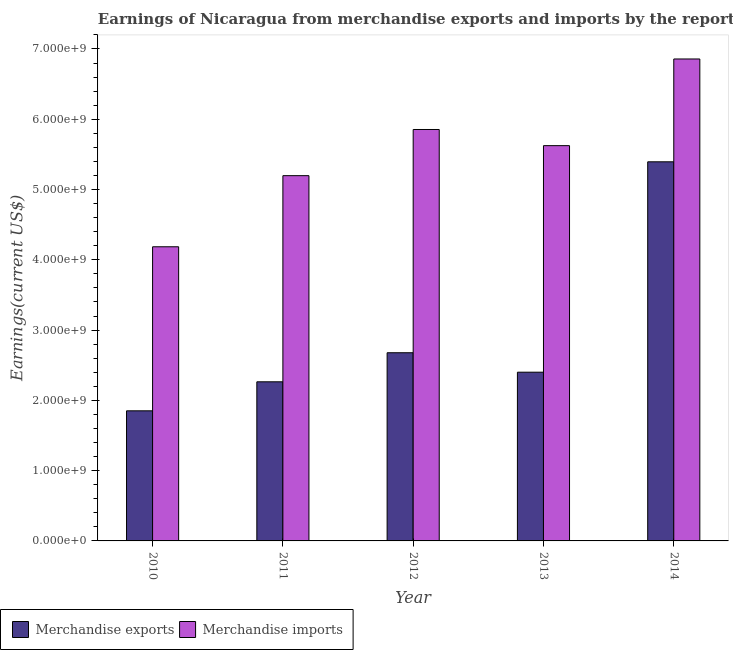How many different coloured bars are there?
Give a very brief answer. 2. How many groups of bars are there?
Your answer should be compact. 5. Are the number of bars per tick equal to the number of legend labels?
Make the answer very short. Yes. How many bars are there on the 2nd tick from the left?
Your answer should be very brief. 2. How many bars are there on the 3rd tick from the right?
Ensure brevity in your answer.  2. What is the earnings from merchandise imports in 2014?
Offer a terse response. 6.86e+09. Across all years, what is the maximum earnings from merchandise exports?
Make the answer very short. 5.39e+09. Across all years, what is the minimum earnings from merchandise imports?
Your response must be concise. 4.19e+09. In which year was the earnings from merchandise exports maximum?
Ensure brevity in your answer.  2014. In which year was the earnings from merchandise exports minimum?
Ensure brevity in your answer.  2010. What is the total earnings from merchandise exports in the graph?
Offer a very short reply. 1.46e+1. What is the difference between the earnings from merchandise imports in 2013 and that in 2014?
Ensure brevity in your answer.  -1.23e+09. What is the difference between the earnings from merchandise exports in 2014 and the earnings from merchandise imports in 2010?
Make the answer very short. 3.54e+09. What is the average earnings from merchandise imports per year?
Offer a terse response. 5.54e+09. In the year 2011, what is the difference between the earnings from merchandise imports and earnings from merchandise exports?
Offer a very short reply. 0. In how many years, is the earnings from merchandise imports greater than 4000000000 US$?
Your answer should be very brief. 5. What is the ratio of the earnings from merchandise exports in 2011 to that in 2013?
Provide a succinct answer. 0.94. Is the earnings from merchandise exports in 2011 less than that in 2013?
Your answer should be very brief. Yes. What is the difference between the highest and the second highest earnings from merchandise exports?
Give a very brief answer. 2.72e+09. What is the difference between the highest and the lowest earnings from merchandise exports?
Provide a succinct answer. 3.54e+09. In how many years, is the earnings from merchandise imports greater than the average earnings from merchandise imports taken over all years?
Provide a succinct answer. 3. Is the sum of the earnings from merchandise imports in 2011 and 2013 greater than the maximum earnings from merchandise exports across all years?
Give a very brief answer. Yes. What does the 1st bar from the left in 2013 represents?
Keep it short and to the point. Merchandise exports. How many bars are there?
Ensure brevity in your answer.  10. Are all the bars in the graph horizontal?
Your answer should be very brief. No. How many years are there in the graph?
Your response must be concise. 5. What is the difference between two consecutive major ticks on the Y-axis?
Your response must be concise. 1.00e+09. Does the graph contain any zero values?
Provide a short and direct response. No. Does the graph contain grids?
Ensure brevity in your answer.  No. How many legend labels are there?
Offer a very short reply. 2. How are the legend labels stacked?
Offer a very short reply. Horizontal. What is the title of the graph?
Offer a terse response. Earnings of Nicaragua from merchandise exports and imports by the reporting economy. What is the label or title of the Y-axis?
Provide a succinct answer. Earnings(current US$). What is the Earnings(current US$) in Merchandise exports in 2010?
Keep it short and to the point. 1.85e+09. What is the Earnings(current US$) of Merchandise imports in 2010?
Your response must be concise. 4.19e+09. What is the Earnings(current US$) of Merchandise exports in 2011?
Your answer should be compact. 2.26e+09. What is the Earnings(current US$) of Merchandise imports in 2011?
Offer a terse response. 5.20e+09. What is the Earnings(current US$) of Merchandise exports in 2012?
Make the answer very short. 2.68e+09. What is the Earnings(current US$) in Merchandise imports in 2012?
Ensure brevity in your answer.  5.85e+09. What is the Earnings(current US$) of Merchandise exports in 2013?
Make the answer very short. 2.40e+09. What is the Earnings(current US$) in Merchandise imports in 2013?
Your response must be concise. 5.62e+09. What is the Earnings(current US$) in Merchandise exports in 2014?
Provide a succinct answer. 5.39e+09. What is the Earnings(current US$) of Merchandise imports in 2014?
Keep it short and to the point. 6.86e+09. Across all years, what is the maximum Earnings(current US$) in Merchandise exports?
Give a very brief answer. 5.39e+09. Across all years, what is the maximum Earnings(current US$) in Merchandise imports?
Keep it short and to the point. 6.86e+09. Across all years, what is the minimum Earnings(current US$) of Merchandise exports?
Give a very brief answer. 1.85e+09. Across all years, what is the minimum Earnings(current US$) of Merchandise imports?
Make the answer very short. 4.19e+09. What is the total Earnings(current US$) in Merchandise exports in the graph?
Your answer should be very brief. 1.46e+1. What is the total Earnings(current US$) in Merchandise imports in the graph?
Ensure brevity in your answer.  2.77e+1. What is the difference between the Earnings(current US$) of Merchandise exports in 2010 and that in 2011?
Give a very brief answer. -4.13e+08. What is the difference between the Earnings(current US$) of Merchandise imports in 2010 and that in 2011?
Keep it short and to the point. -1.01e+09. What is the difference between the Earnings(current US$) in Merchandise exports in 2010 and that in 2012?
Keep it short and to the point. -8.26e+08. What is the difference between the Earnings(current US$) in Merchandise imports in 2010 and that in 2012?
Give a very brief answer. -1.67e+09. What is the difference between the Earnings(current US$) of Merchandise exports in 2010 and that in 2013?
Your answer should be compact. -5.50e+08. What is the difference between the Earnings(current US$) in Merchandise imports in 2010 and that in 2013?
Offer a terse response. -1.44e+09. What is the difference between the Earnings(current US$) of Merchandise exports in 2010 and that in 2014?
Offer a very short reply. -3.54e+09. What is the difference between the Earnings(current US$) in Merchandise imports in 2010 and that in 2014?
Your response must be concise. -2.67e+09. What is the difference between the Earnings(current US$) in Merchandise exports in 2011 and that in 2012?
Offer a terse response. -4.13e+08. What is the difference between the Earnings(current US$) of Merchandise imports in 2011 and that in 2012?
Your answer should be very brief. -6.57e+08. What is the difference between the Earnings(current US$) in Merchandise exports in 2011 and that in 2013?
Make the answer very short. -1.37e+08. What is the difference between the Earnings(current US$) of Merchandise imports in 2011 and that in 2013?
Provide a succinct answer. -4.27e+08. What is the difference between the Earnings(current US$) of Merchandise exports in 2011 and that in 2014?
Ensure brevity in your answer.  -3.13e+09. What is the difference between the Earnings(current US$) in Merchandise imports in 2011 and that in 2014?
Your answer should be compact. -1.66e+09. What is the difference between the Earnings(current US$) in Merchandise exports in 2012 and that in 2013?
Make the answer very short. 2.77e+08. What is the difference between the Earnings(current US$) in Merchandise imports in 2012 and that in 2013?
Your response must be concise. 2.30e+08. What is the difference between the Earnings(current US$) of Merchandise exports in 2012 and that in 2014?
Your response must be concise. -2.72e+09. What is the difference between the Earnings(current US$) of Merchandise imports in 2012 and that in 2014?
Offer a very short reply. -1.00e+09. What is the difference between the Earnings(current US$) of Merchandise exports in 2013 and that in 2014?
Your answer should be compact. -2.99e+09. What is the difference between the Earnings(current US$) of Merchandise imports in 2013 and that in 2014?
Your answer should be very brief. -1.23e+09. What is the difference between the Earnings(current US$) in Merchandise exports in 2010 and the Earnings(current US$) in Merchandise imports in 2011?
Provide a short and direct response. -3.35e+09. What is the difference between the Earnings(current US$) in Merchandise exports in 2010 and the Earnings(current US$) in Merchandise imports in 2012?
Your answer should be compact. -4.00e+09. What is the difference between the Earnings(current US$) in Merchandise exports in 2010 and the Earnings(current US$) in Merchandise imports in 2013?
Provide a short and direct response. -3.77e+09. What is the difference between the Earnings(current US$) in Merchandise exports in 2010 and the Earnings(current US$) in Merchandise imports in 2014?
Your answer should be compact. -5.01e+09. What is the difference between the Earnings(current US$) of Merchandise exports in 2011 and the Earnings(current US$) of Merchandise imports in 2012?
Provide a short and direct response. -3.59e+09. What is the difference between the Earnings(current US$) of Merchandise exports in 2011 and the Earnings(current US$) of Merchandise imports in 2013?
Your answer should be very brief. -3.36e+09. What is the difference between the Earnings(current US$) of Merchandise exports in 2011 and the Earnings(current US$) of Merchandise imports in 2014?
Keep it short and to the point. -4.59e+09. What is the difference between the Earnings(current US$) in Merchandise exports in 2012 and the Earnings(current US$) in Merchandise imports in 2013?
Offer a very short reply. -2.95e+09. What is the difference between the Earnings(current US$) in Merchandise exports in 2012 and the Earnings(current US$) in Merchandise imports in 2014?
Offer a very short reply. -4.18e+09. What is the difference between the Earnings(current US$) of Merchandise exports in 2013 and the Earnings(current US$) of Merchandise imports in 2014?
Provide a short and direct response. -4.46e+09. What is the average Earnings(current US$) of Merchandise exports per year?
Keep it short and to the point. 2.92e+09. What is the average Earnings(current US$) of Merchandise imports per year?
Offer a terse response. 5.54e+09. In the year 2010, what is the difference between the Earnings(current US$) in Merchandise exports and Earnings(current US$) in Merchandise imports?
Provide a short and direct response. -2.33e+09. In the year 2011, what is the difference between the Earnings(current US$) of Merchandise exports and Earnings(current US$) of Merchandise imports?
Give a very brief answer. -2.93e+09. In the year 2012, what is the difference between the Earnings(current US$) of Merchandise exports and Earnings(current US$) of Merchandise imports?
Your response must be concise. -3.18e+09. In the year 2013, what is the difference between the Earnings(current US$) of Merchandise exports and Earnings(current US$) of Merchandise imports?
Provide a short and direct response. -3.22e+09. In the year 2014, what is the difference between the Earnings(current US$) in Merchandise exports and Earnings(current US$) in Merchandise imports?
Ensure brevity in your answer.  -1.46e+09. What is the ratio of the Earnings(current US$) of Merchandise exports in 2010 to that in 2011?
Make the answer very short. 0.82. What is the ratio of the Earnings(current US$) of Merchandise imports in 2010 to that in 2011?
Provide a short and direct response. 0.81. What is the ratio of the Earnings(current US$) in Merchandise exports in 2010 to that in 2012?
Provide a succinct answer. 0.69. What is the ratio of the Earnings(current US$) in Merchandise imports in 2010 to that in 2012?
Your answer should be compact. 0.71. What is the ratio of the Earnings(current US$) of Merchandise exports in 2010 to that in 2013?
Ensure brevity in your answer.  0.77. What is the ratio of the Earnings(current US$) of Merchandise imports in 2010 to that in 2013?
Give a very brief answer. 0.74. What is the ratio of the Earnings(current US$) in Merchandise exports in 2010 to that in 2014?
Your answer should be compact. 0.34. What is the ratio of the Earnings(current US$) of Merchandise imports in 2010 to that in 2014?
Provide a short and direct response. 0.61. What is the ratio of the Earnings(current US$) in Merchandise exports in 2011 to that in 2012?
Your answer should be compact. 0.85. What is the ratio of the Earnings(current US$) of Merchandise imports in 2011 to that in 2012?
Your response must be concise. 0.89. What is the ratio of the Earnings(current US$) of Merchandise exports in 2011 to that in 2013?
Make the answer very short. 0.94. What is the ratio of the Earnings(current US$) of Merchandise imports in 2011 to that in 2013?
Your answer should be compact. 0.92. What is the ratio of the Earnings(current US$) of Merchandise exports in 2011 to that in 2014?
Ensure brevity in your answer.  0.42. What is the ratio of the Earnings(current US$) of Merchandise imports in 2011 to that in 2014?
Ensure brevity in your answer.  0.76. What is the ratio of the Earnings(current US$) in Merchandise exports in 2012 to that in 2013?
Offer a terse response. 1.12. What is the ratio of the Earnings(current US$) of Merchandise imports in 2012 to that in 2013?
Offer a very short reply. 1.04. What is the ratio of the Earnings(current US$) in Merchandise exports in 2012 to that in 2014?
Provide a succinct answer. 0.5. What is the ratio of the Earnings(current US$) of Merchandise imports in 2012 to that in 2014?
Give a very brief answer. 0.85. What is the ratio of the Earnings(current US$) in Merchandise exports in 2013 to that in 2014?
Offer a terse response. 0.45. What is the ratio of the Earnings(current US$) in Merchandise imports in 2013 to that in 2014?
Provide a short and direct response. 0.82. What is the difference between the highest and the second highest Earnings(current US$) of Merchandise exports?
Provide a short and direct response. 2.72e+09. What is the difference between the highest and the second highest Earnings(current US$) of Merchandise imports?
Your response must be concise. 1.00e+09. What is the difference between the highest and the lowest Earnings(current US$) of Merchandise exports?
Keep it short and to the point. 3.54e+09. What is the difference between the highest and the lowest Earnings(current US$) of Merchandise imports?
Your answer should be very brief. 2.67e+09. 